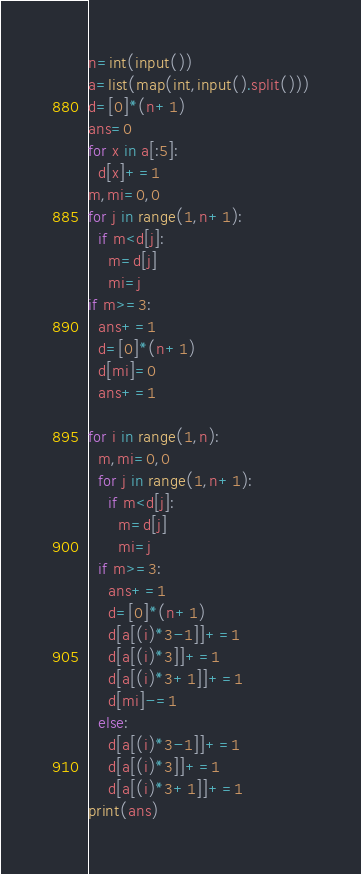Convert code to text. <code><loc_0><loc_0><loc_500><loc_500><_Python_>n=int(input())
a=list(map(int,input().split()))
d=[0]*(n+1)
ans=0
for x in a[:5]:
  d[x]+=1
m,mi=0,0
for j in range(1,n+1):
  if m<d[j]:
    m=d[j]
    mi=j
if m>=3:
  ans+=1
  d=[0]*(n+1)
  d[mi]=0
  ans+=1

for i in range(1,n):
  m,mi=0,0
  for j in range(1,n+1):
    if m<d[j]:
      m=d[j]
      mi=j
  if m>=3:
    ans+=1
    d=[0]*(n+1)
    d[a[(i)*3-1]]+=1
    d[a[(i)*3]]+=1
    d[a[(i)*3+1]]+=1
    d[mi]-=1
  else:
    d[a[(i)*3-1]]+=1
    d[a[(i)*3]]+=1
    d[a[(i)*3+1]]+=1
print(ans)
</code> 